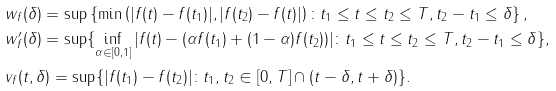<formula> <loc_0><loc_0><loc_500><loc_500>& w _ { f } ( \delta ) = \sup \left \{ \min \left ( | f ( t ) - f ( t _ { 1 } ) | , | f ( t _ { 2 } ) - f ( t ) | \right ) \colon t _ { 1 } \leq t \leq t _ { 2 } \leq T , t _ { 2 } - t _ { 1 } \leq \delta \right \} , \\ & w ^ { \prime } _ { f } ( \delta ) = \sup \{ \inf _ { \alpha \in [ 0 , 1 ] } | f ( t ) - ( \alpha f ( t _ { 1 } ) + ( 1 - \alpha ) f ( t _ { 2 } ) ) | \colon t _ { 1 } \leq t \leq t _ { 2 } \leq T , t _ { 2 } - t _ { 1 } \leq \delta \} , \\ & v _ { f } ( t , \delta ) = \sup \{ | f ( t _ { 1 } ) - f ( t _ { 2 } ) | \colon t _ { 1 } , t _ { 2 } \in [ 0 , T ] \cap ( t - \delta , t + \delta ) \} .</formula> 